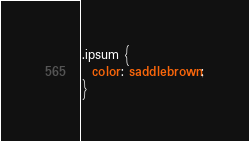Convert code to text. <code><loc_0><loc_0><loc_500><loc_500><_CSS_>.ipsum {
  color: saddlebrown;
}
</code> 